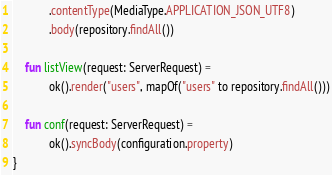Convert code to text. <code><loc_0><loc_0><loc_500><loc_500><_Kotlin_>			.contentType(MediaType.APPLICATION_JSON_UTF8)
			.body(repository.findAll())

	fun listView(request: ServerRequest) =
			ok().render("users", mapOf("users" to repository.findAll()))

	fun conf(request: ServerRequest) =
			ok().syncBody(configuration.property)
}</code> 